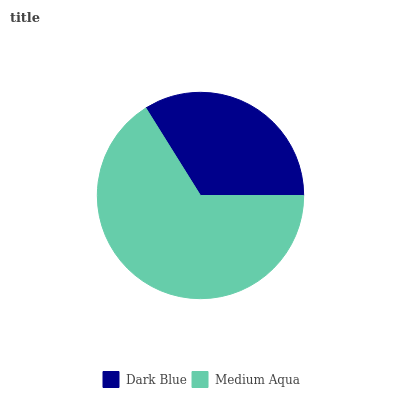Is Dark Blue the minimum?
Answer yes or no. Yes. Is Medium Aqua the maximum?
Answer yes or no. Yes. Is Medium Aqua the minimum?
Answer yes or no. No. Is Medium Aqua greater than Dark Blue?
Answer yes or no. Yes. Is Dark Blue less than Medium Aqua?
Answer yes or no. Yes. Is Dark Blue greater than Medium Aqua?
Answer yes or no. No. Is Medium Aqua less than Dark Blue?
Answer yes or no. No. Is Medium Aqua the high median?
Answer yes or no. Yes. Is Dark Blue the low median?
Answer yes or no. Yes. Is Dark Blue the high median?
Answer yes or no. No. Is Medium Aqua the low median?
Answer yes or no. No. 